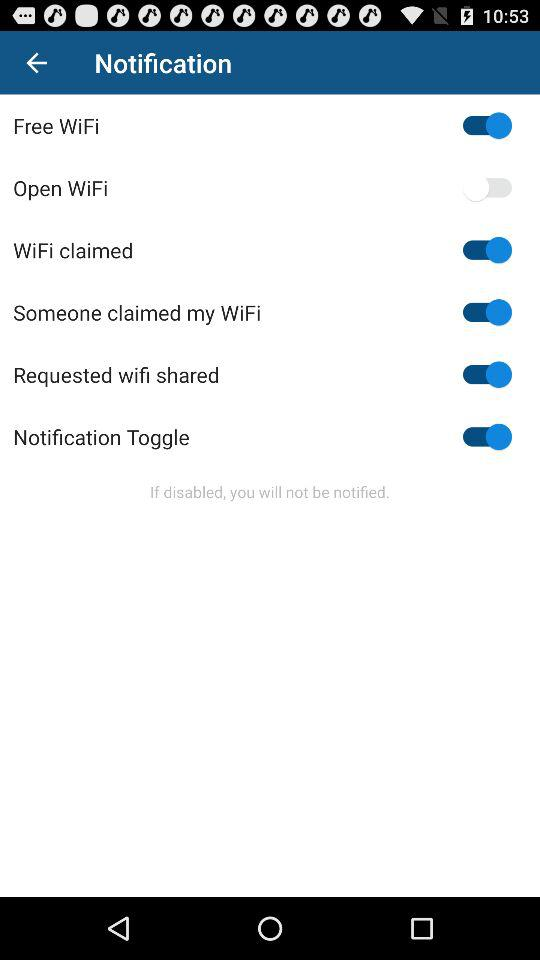What is the status of open WiFi? The status of open WiFi is off. 